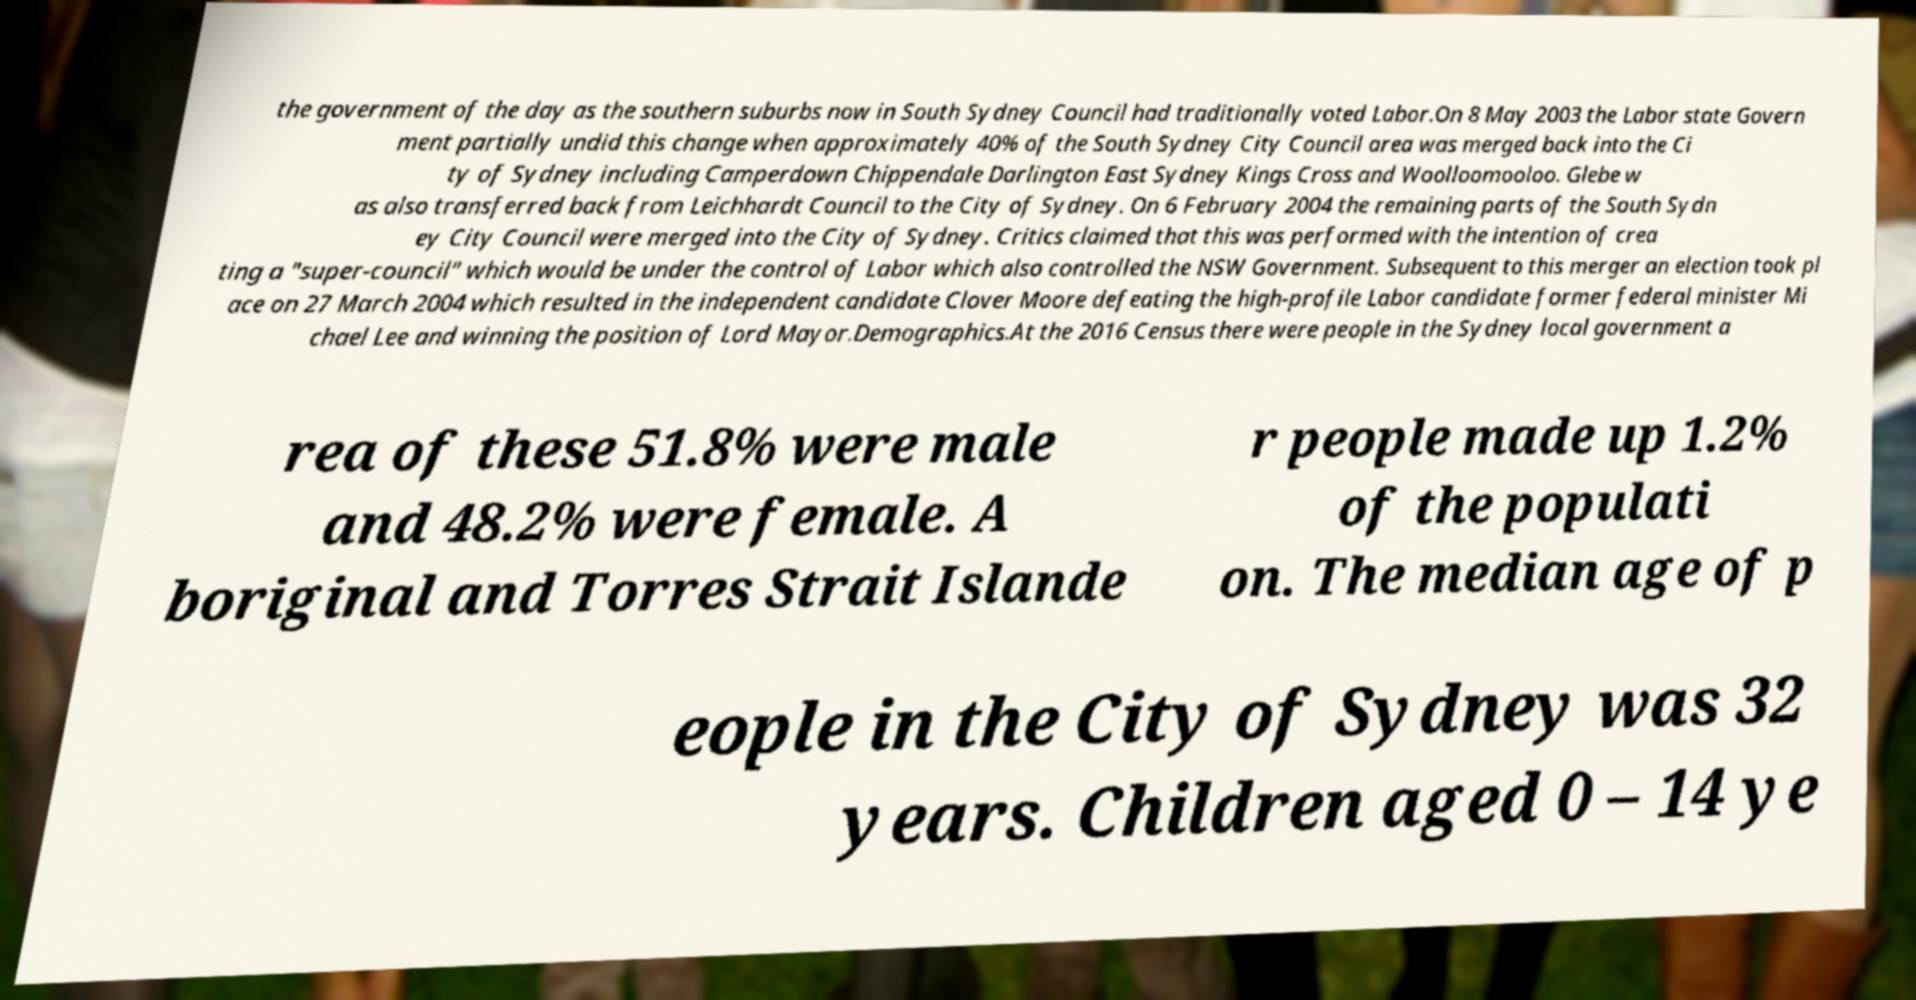Please identify and transcribe the text found in this image. the government of the day as the southern suburbs now in South Sydney Council had traditionally voted Labor.On 8 May 2003 the Labor state Govern ment partially undid this change when approximately 40% of the South Sydney City Council area was merged back into the Ci ty of Sydney including Camperdown Chippendale Darlington East Sydney Kings Cross and Woolloomooloo. Glebe w as also transferred back from Leichhardt Council to the City of Sydney. On 6 February 2004 the remaining parts of the South Sydn ey City Council were merged into the City of Sydney. Critics claimed that this was performed with the intention of crea ting a "super-council" which would be under the control of Labor which also controlled the NSW Government. Subsequent to this merger an election took pl ace on 27 March 2004 which resulted in the independent candidate Clover Moore defeating the high-profile Labor candidate former federal minister Mi chael Lee and winning the position of Lord Mayor.Demographics.At the 2016 Census there were people in the Sydney local government a rea of these 51.8% were male and 48.2% were female. A boriginal and Torres Strait Islande r people made up 1.2% of the populati on. The median age of p eople in the City of Sydney was 32 years. Children aged 0 – 14 ye 